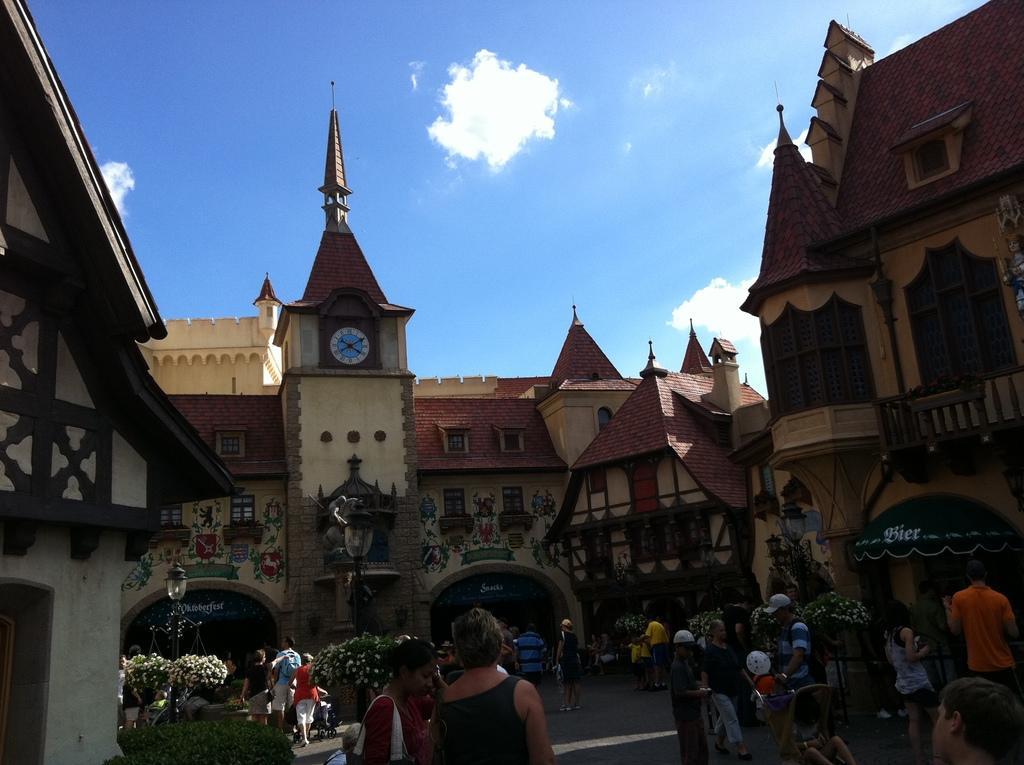How would you summarize this image in a sentence or two? This is an outside view. At the bottom, I can see some people on the ground and also there are some plants. In the background there are buildings. At the top of the image I can see the sky and clouds. 